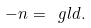Convert formula to latex. <formula><loc_0><loc_0><loc_500><loc_500>- n = \ g l d .</formula> 